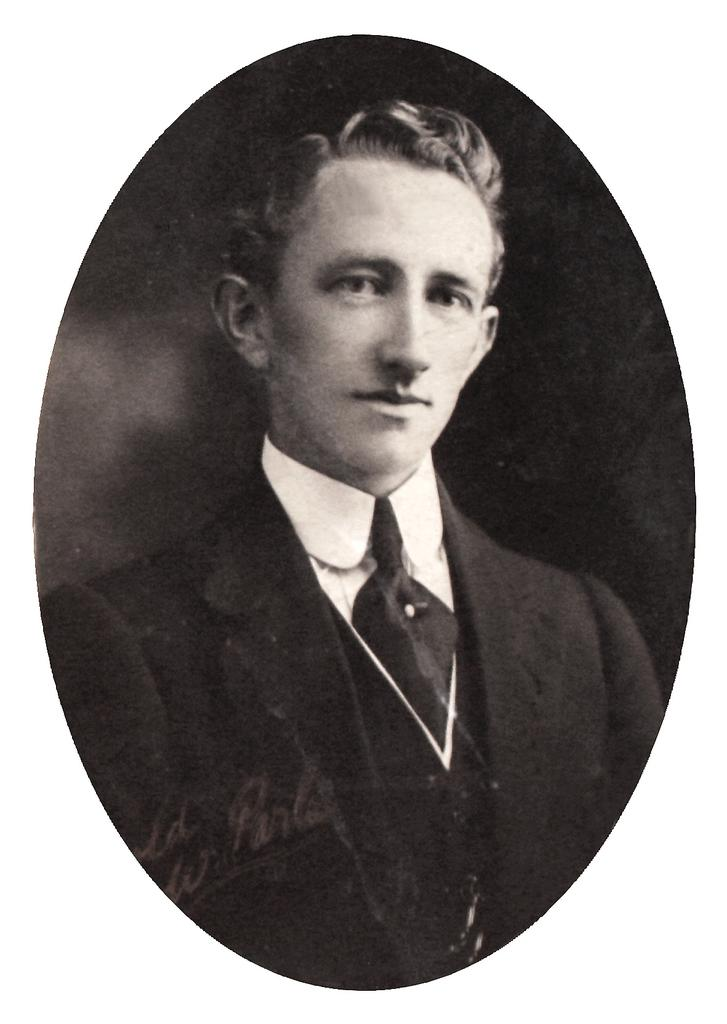What is the color scheme of the image? The image is black and white. Who is present in the image? There is a man in a suit in the image. Are there any words or letters in the image? Yes, there is text on the image. What color is the background of the image? The background of the image is black. How many apples are hanging from the man's suit in the image? There are no apples present in the image. What type of nerve is visible in the man's suit in the image? There are no nerves visible in the image, as it is a black and white image of a man in a suit with text. 